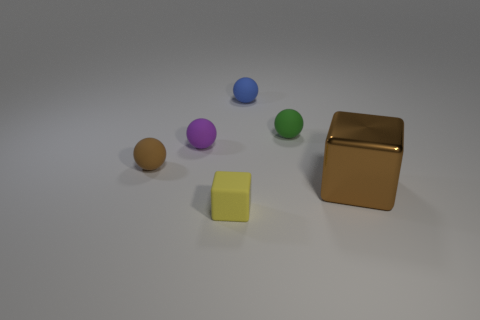Subtract 1 balls. How many balls are left? 3 Add 2 large yellow rubber spheres. How many objects exist? 8 Subtract all cubes. How many objects are left? 4 Subtract all purple matte objects. Subtract all tiny blue matte spheres. How many objects are left? 4 Add 6 brown metallic cubes. How many brown metallic cubes are left? 7 Add 2 metal cylinders. How many metal cylinders exist? 2 Subtract 0 brown cylinders. How many objects are left? 6 